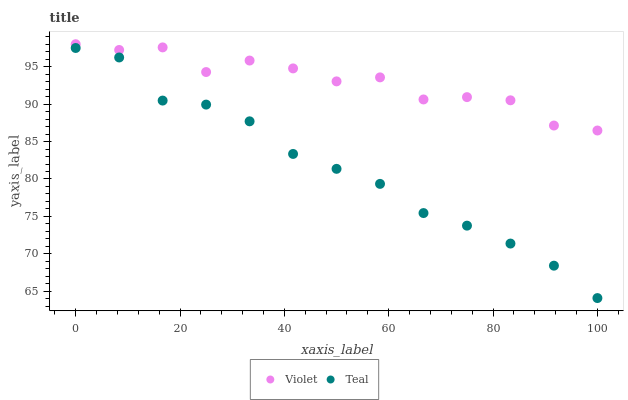Does Teal have the minimum area under the curve?
Answer yes or no. Yes. Does Violet have the maximum area under the curve?
Answer yes or no. Yes. Does Violet have the minimum area under the curve?
Answer yes or no. No. Is Teal the smoothest?
Answer yes or no. Yes. Is Violet the roughest?
Answer yes or no. Yes. Is Violet the smoothest?
Answer yes or no. No. Does Teal have the lowest value?
Answer yes or no. Yes. Does Violet have the lowest value?
Answer yes or no. No. Does Violet have the highest value?
Answer yes or no. Yes. Is Teal less than Violet?
Answer yes or no. Yes. Is Violet greater than Teal?
Answer yes or no. Yes. Does Teal intersect Violet?
Answer yes or no. No. 